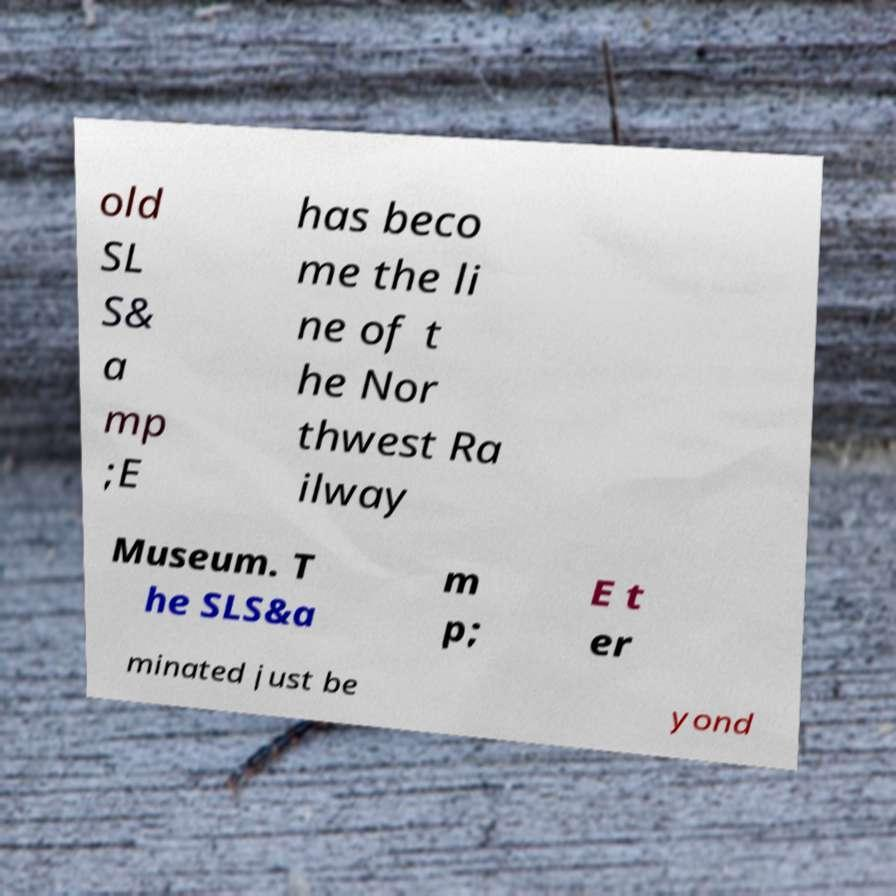Please identify and transcribe the text found in this image. old SL S& a mp ;E has beco me the li ne of t he Nor thwest Ra ilway Museum. T he SLS&a m p; E t er minated just be yond 